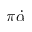<formula> <loc_0><loc_0><loc_500><loc_500>\pi \dot { \alpha }</formula> 